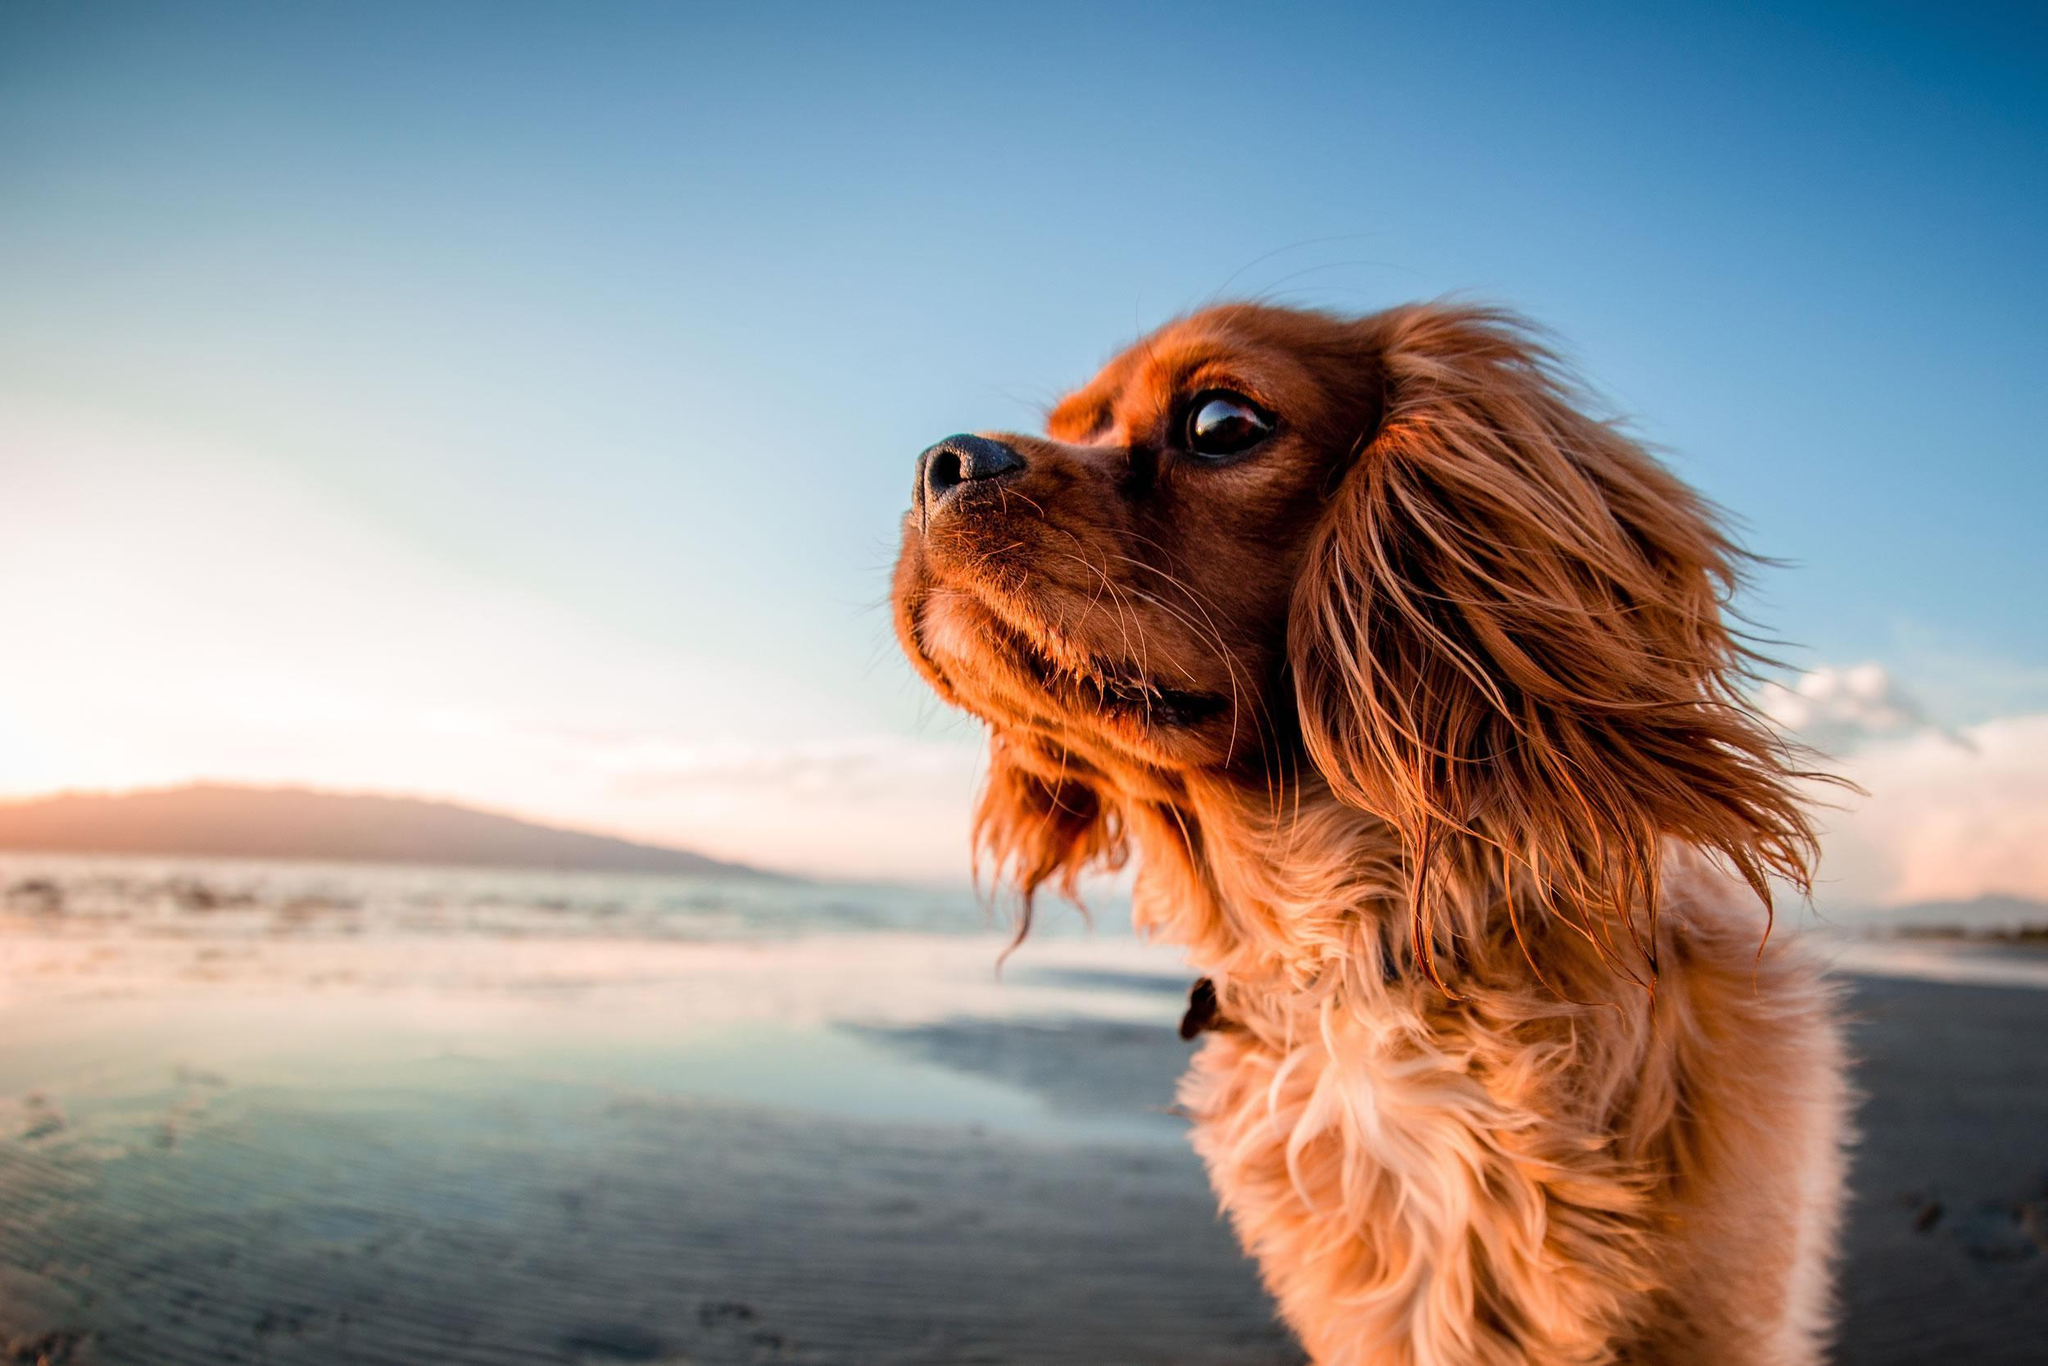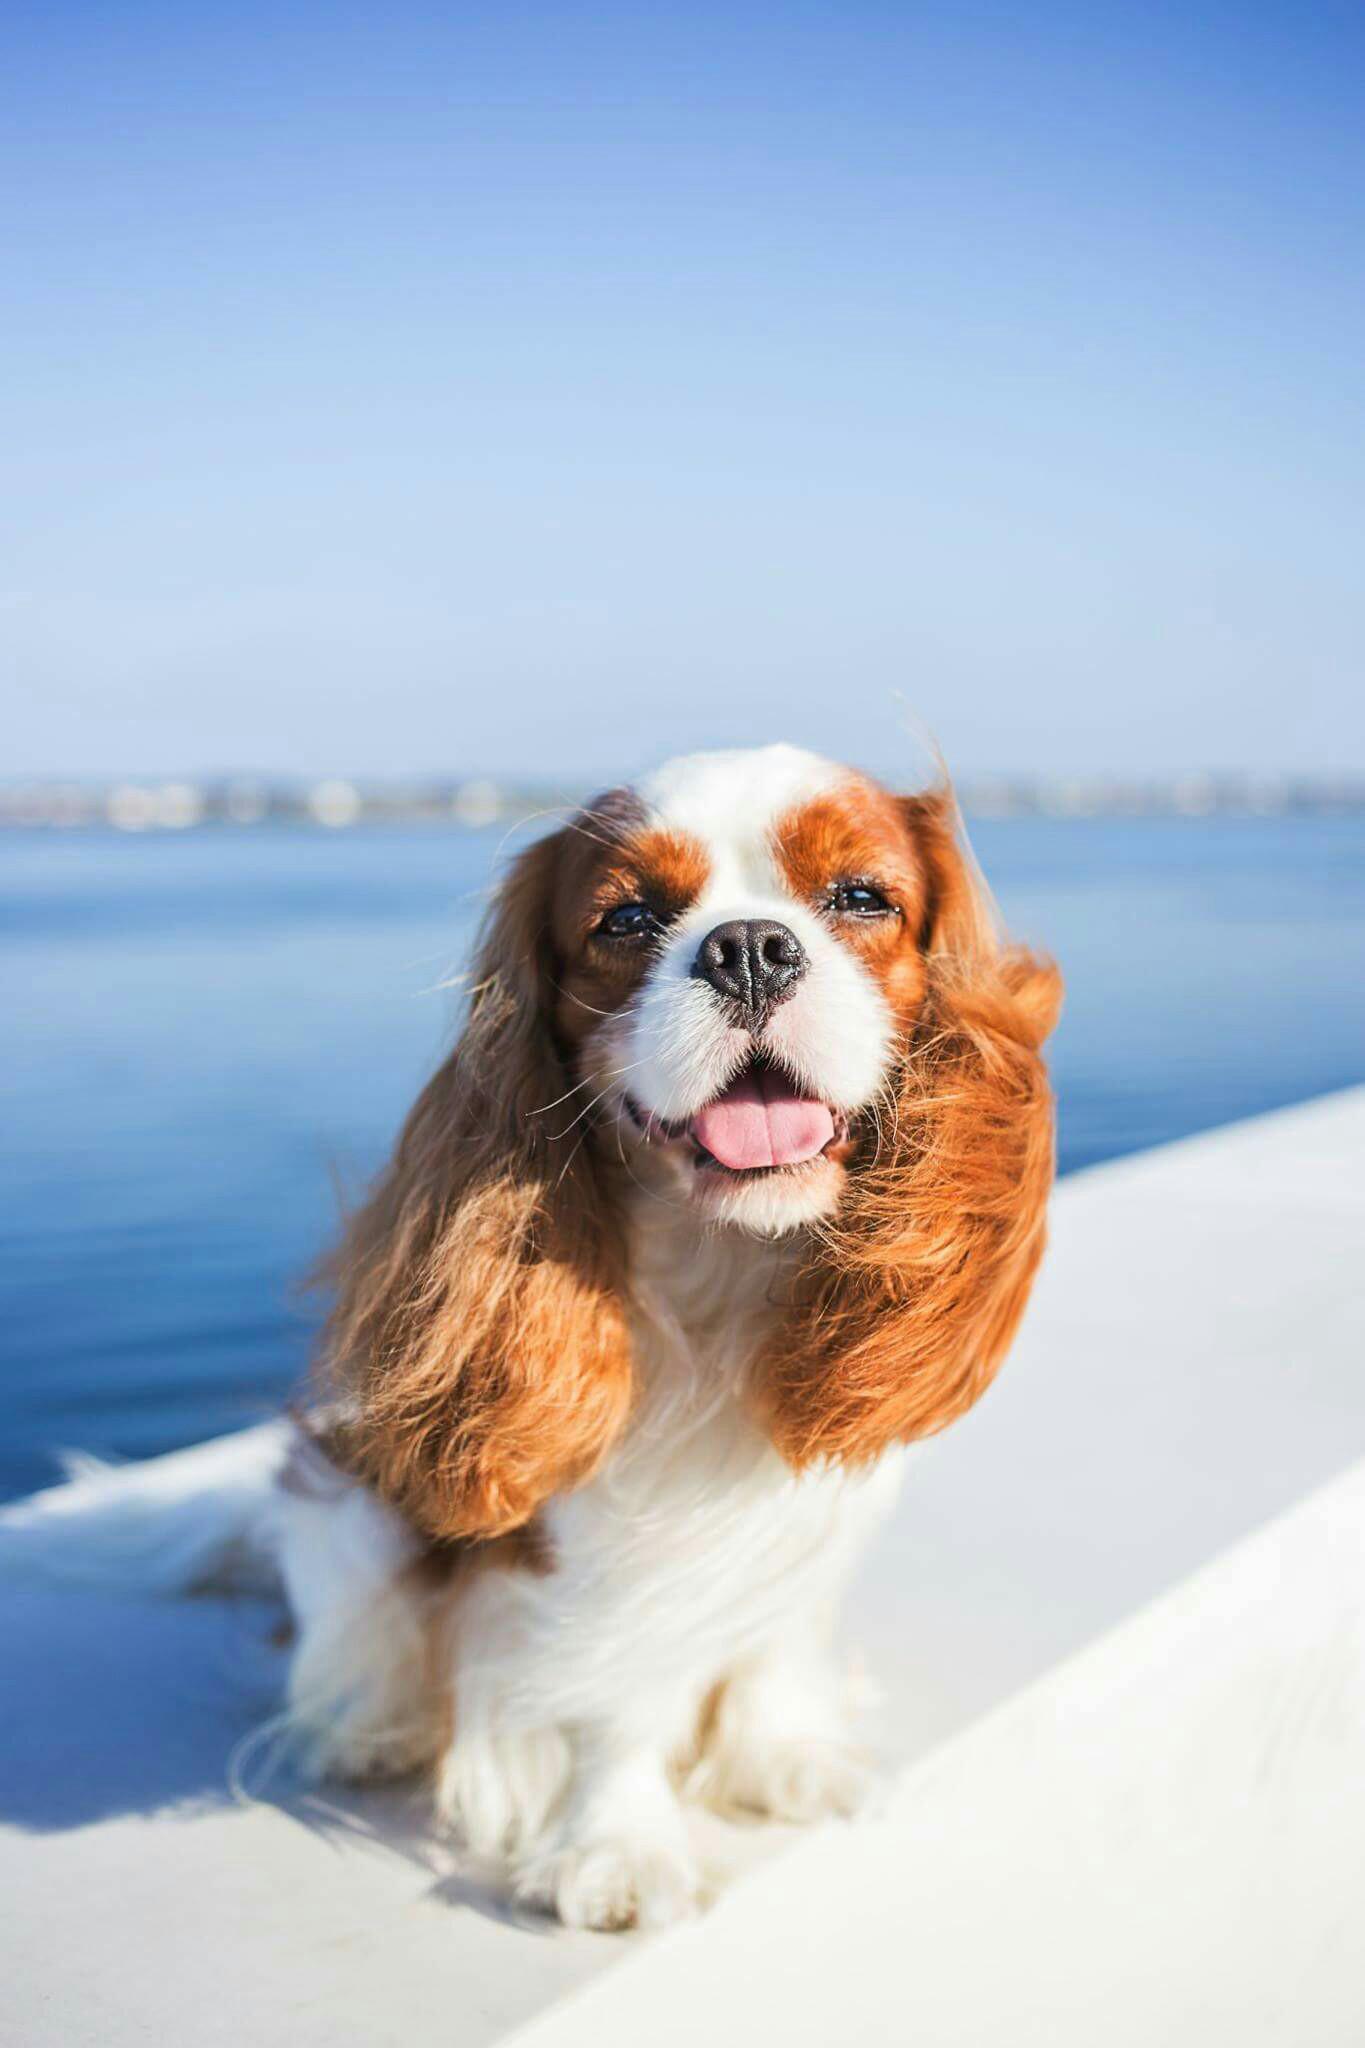The first image is the image on the left, the second image is the image on the right. Assess this claim about the two images: "There are three mammals visible". Correct or not? Answer yes or no. No. The first image is the image on the left, the second image is the image on the right. Assess this claim about the two images: "There is a single dog outside in each image.". Correct or not? Answer yes or no. Yes. 